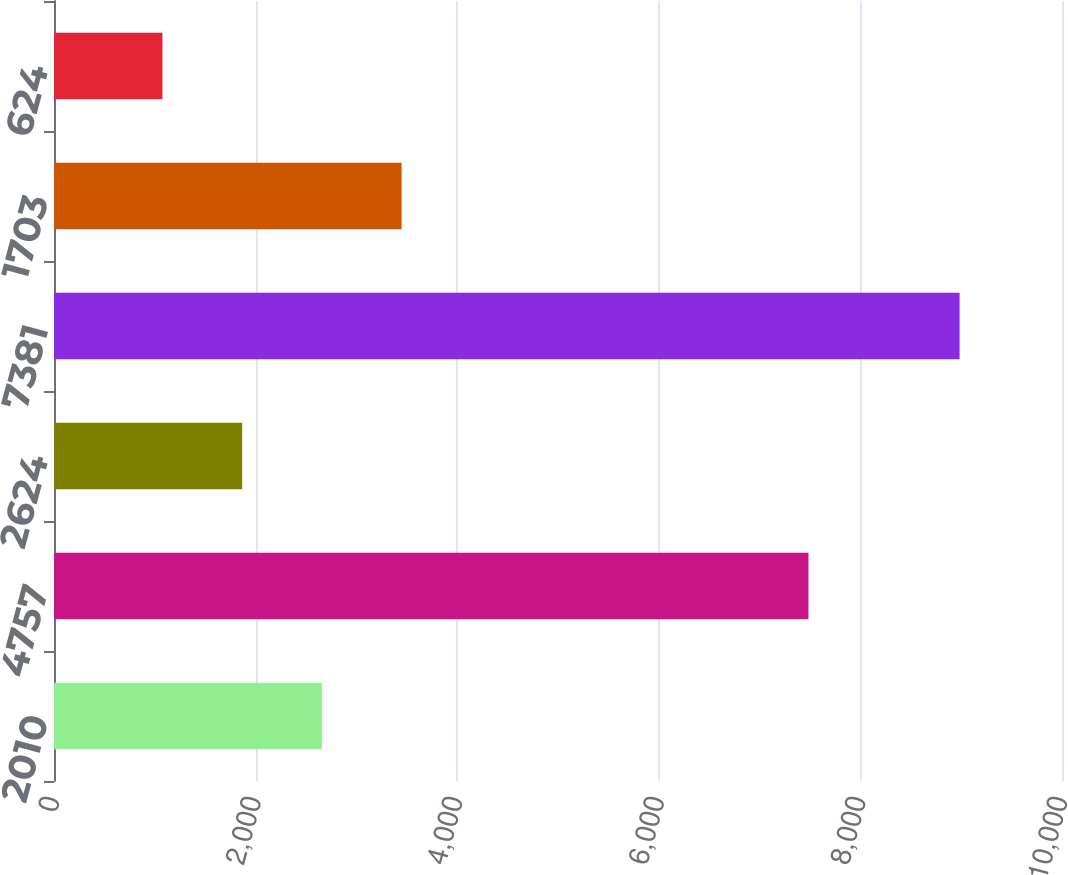<chart> <loc_0><loc_0><loc_500><loc_500><bar_chart><fcel>2010<fcel>4757<fcel>2624<fcel>7381<fcel>1703<fcel>624<nl><fcel>2657.6<fcel>7485<fcel>1866.8<fcel>8984<fcel>3448.4<fcel>1076<nl></chart> 